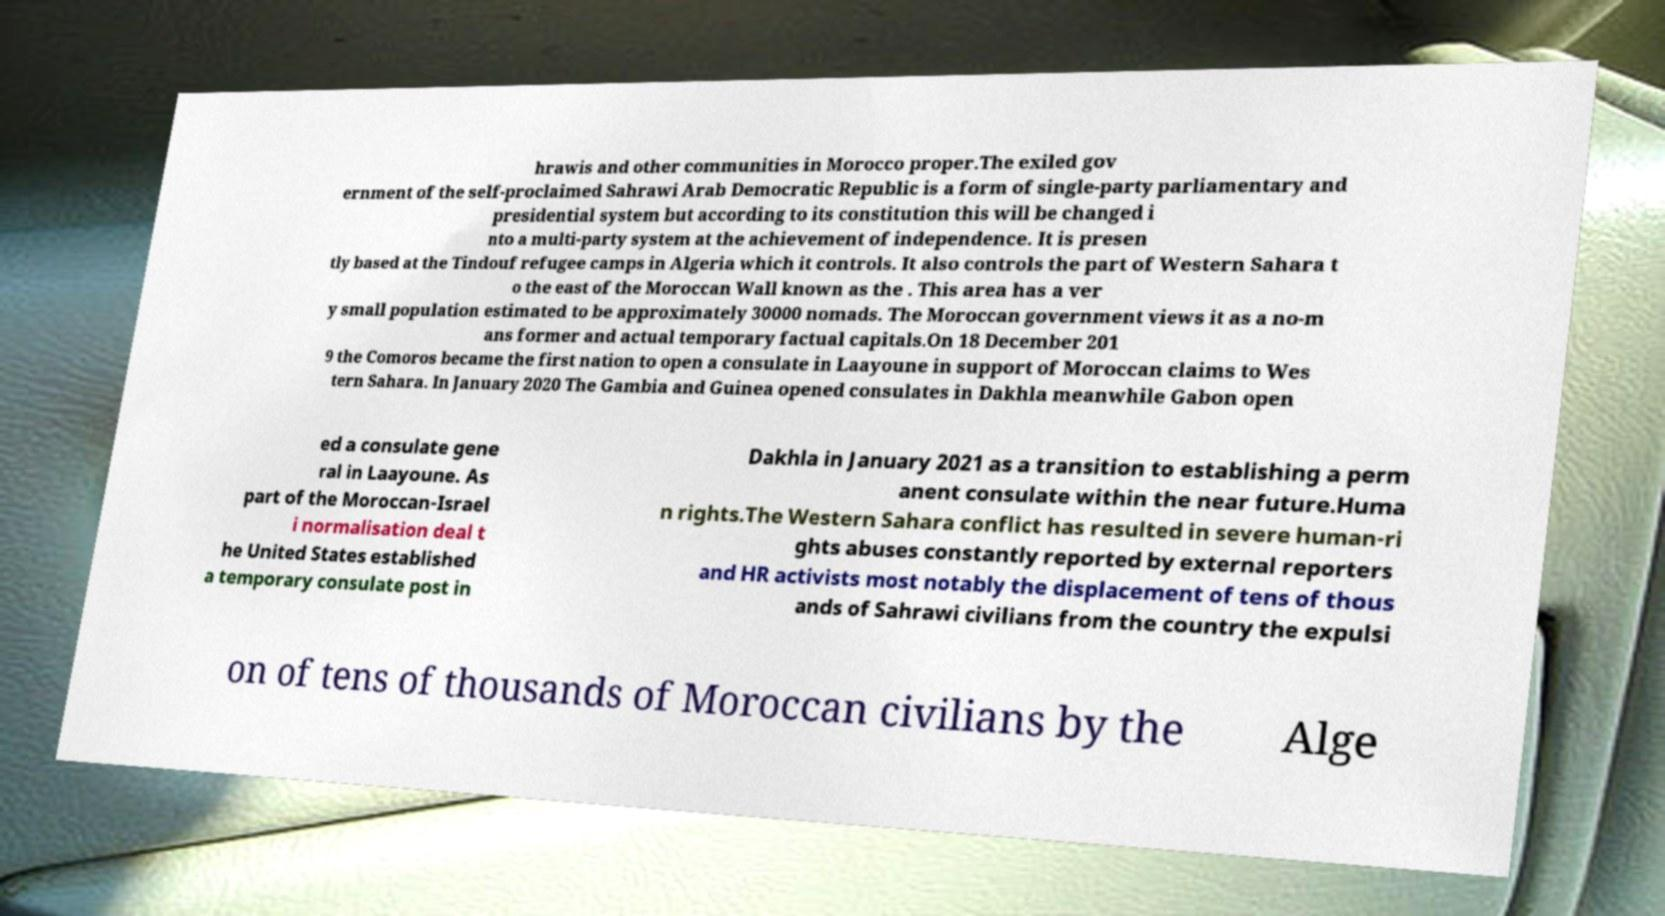Please read and relay the text visible in this image. What does it say? hrawis and other communities in Morocco proper.The exiled gov ernment of the self-proclaimed Sahrawi Arab Democratic Republic is a form of single-party parliamentary and presidential system but according to its constitution this will be changed i nto a multi-party system at the achievement of independence. It is presen tly based at the Tindouf refugee camps in Algeria which it controls. It also controls the part of Western Sahara t o the east of the Moroccan Wall known as the . This area has a ver y small population estimated to be approximately 30000 nomads. The Moroccan government views it as a no-m ans former and actual temporary factual capitals.On 18 December 201 9 the Comoros became the first nation to open a consulate in Laayoune in support of Moroccan claims to Wes tern Sahara. In January 2020 The Gambia and Guinea opened consulates in Dakhla meanwhile Gabon open ed a consulate gene ral in Laayoune. As part of the Moroccan-Israel i normalisation deal t he United States established a temporary consulate post in Dakhla in January 2021 as a transition to establishing a perm anent consulate within the near future.Huma n rights.The Western Sahara conflict has resulted in severe human-ri ghts abuses constantly reported by external reporters and HR activists most notably the displacement of tens of thous ands of Sahrawi civilians from the country the expulsi on of tens of thousands of Moroccan civilians by the Alge 